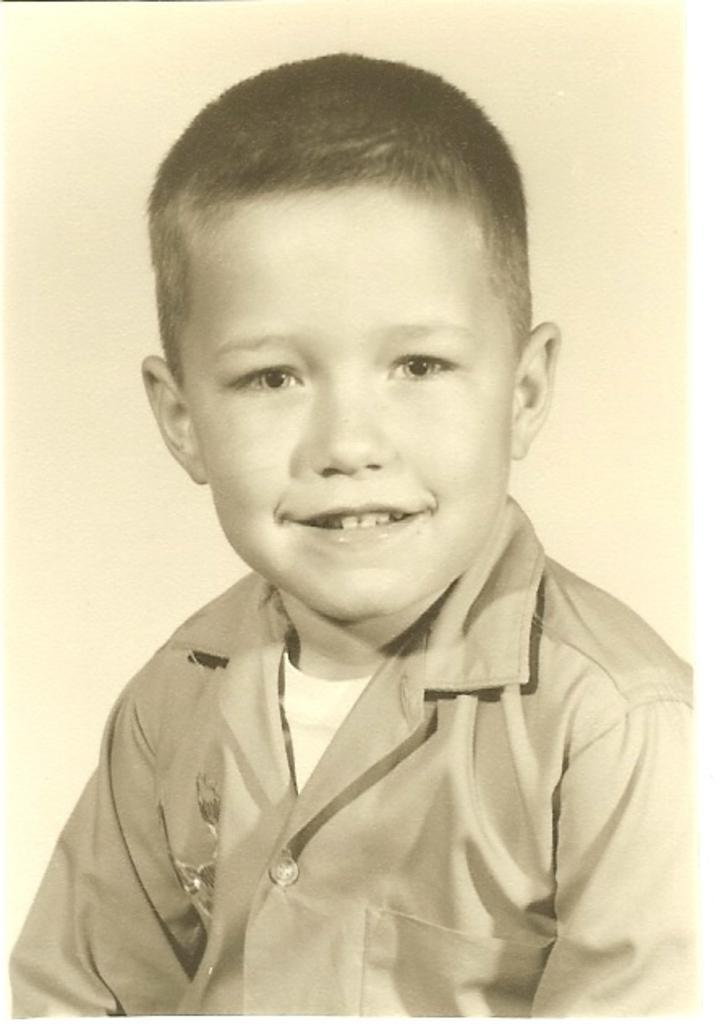Who is present in the image? There is a boy in the image. What is the boy's facial expression? The boy is smiling. What type of map can be seen in the image? There is no map present in the image; it only features a boy who is smiling. 